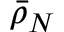<formula> <loc_0><loc_0><loc_500><loc_500>\bar { \rho } _ { N }</formula> 